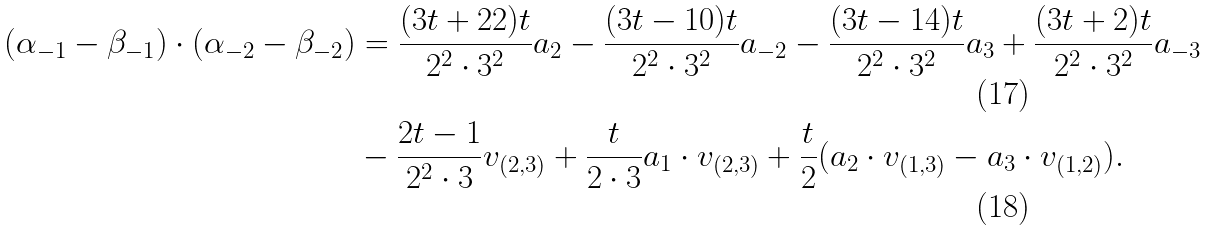Convert formula to latex. <formula><loc_0><loc_0><loc_500><loc_500>( \alpha _ { - 1 } - \beta _ { - 1 } ) \cdot ( \alpha _ { - 2 } - \beta _ { - 2 } ) & = \frac { ( 3 t + 2 2 ) t } { 2 ^ { 2 } \cdot 3 ^ { 2 } } a _ { 2 } - \frac { ( 3 t - 1 0 ) t } { 2 ^ { 2 } \cdot 3 ^ { 2 } } a _ { - 2 } - \frac { ( 3 t - 1 4 ) t } { 2 ^ { 2 } \cdot 3 ^ { 2 } } a _ { 3 } + \frac { ( 3 t + 2 ) t } { 2 ^ { 2 } \cdot 3 ^ { 2 } } a _ { - 3 } \\ & - \frac { 2 t - 1 } { 2 ^ { 2 } \cdot 3 } v _ { ( 2 , 3 ) } + \frac { t } { 2 \cdot 3 } a _ { 1 } \cdot v _ { ( 2 , 3 ) } + \frac { t } { 2 } ( a _ { 2 } \cdot v _ { ( 1 , 3 ) } - a _ { 3 } \cdot v _ { ( 1 , 2 ) } ) .</formula> 